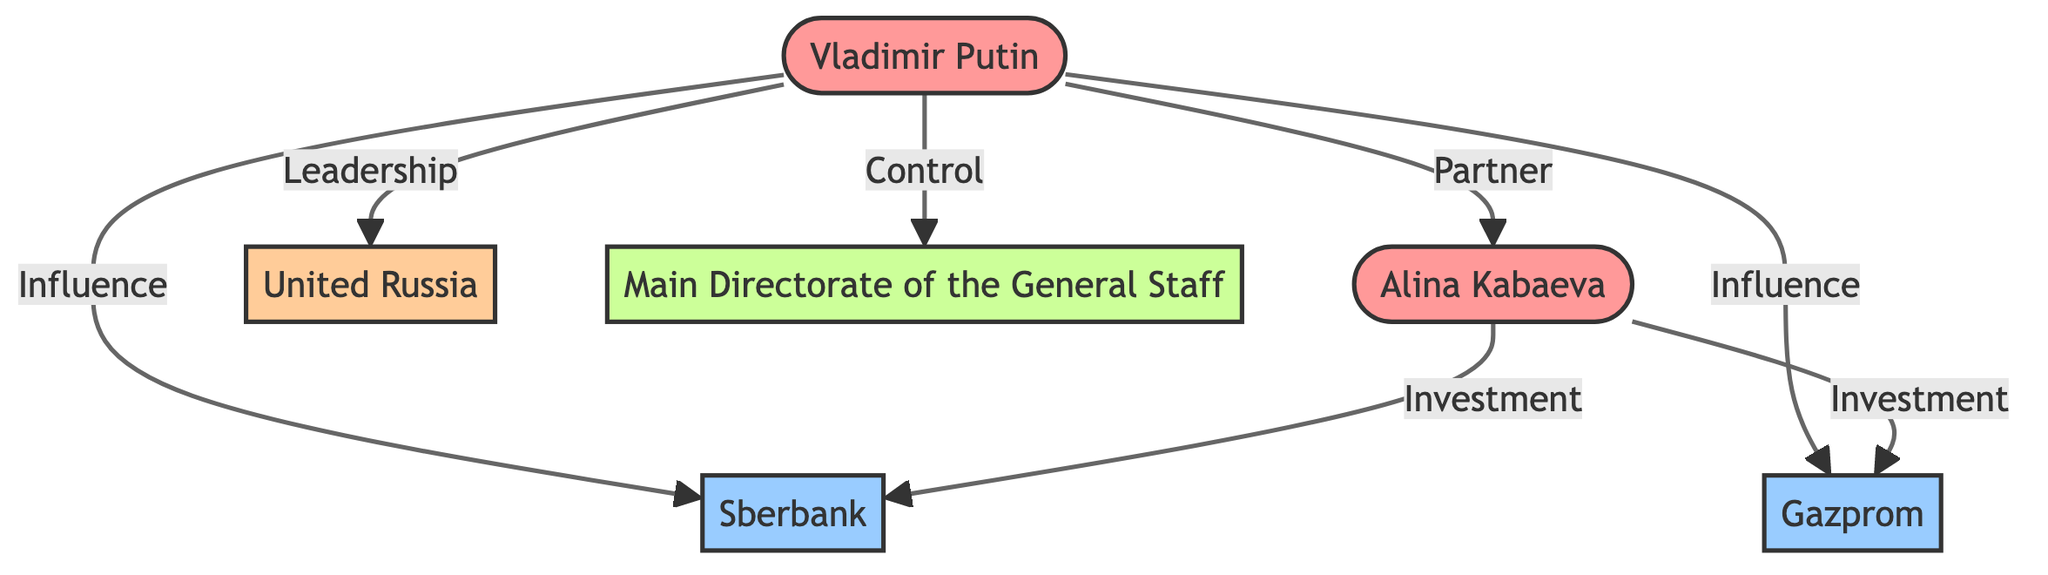What is the total number of nodes in the diagram? The diagram consists of six nodes: Vladimir Putin, Alina Kabaeva, Sberbank, Gazprom, United Russia, and the Main Directorate of the General Staff. Therefore, the total is six.
Answer: 6 Who has a partner relationship with Vladimir Putin? According to the diagram, Vladimir Putin is connected to Alina Kabaeva through a partner relationship.
Answer: Alina Kabaeva What type of organization is Sberbank? Sberbank is classified as an Organization in the diagram. This can be confirmed by its designation in the node's type.
Answer: Organization What relationship does Vladimir Putin have with Gazprom? The diagram shows that Vladimir Putin has an "Influence" relationship with Gazprom, indicated by the directed edge connecting these two nodes.
Answer: Influence How many investments did Alina Kabaeva make? Alina Kabaeva is connected to two organizations (Sberbank and Gazprom) through an investment relationship, which counts as two distinct investments.
Answer: 2 What is the relationship type between Vladimir Putin and the Main Directorate of the General Staff? The diagram indicates that the relationship between Vladimir Putin and the Main Directorate of the General Staff is "Control," which is specified on the edge connecting them.
Answer: Control Which organization is under the leadership of Vladimir Putin? The directed edge in the diagram shows that Vladimir Putin leads the United Russia political party, which can be confirmed through the relationship labeled "Leadership."
Answer: United Russia Identify the type associated with Alina Kabaeva. In the diagram, Alina Kabaeva is classified as an Individual, which is clearly stated in her node's type description.
Answer: Individual Which entity influences both Sberbank and Gazprom? The diagram illustrates that Vladimir Putin has an influence on both Sberbank and Gazprom, as shown by the two directed edges from him to these organizations.
Answer: Vladimir Putin 